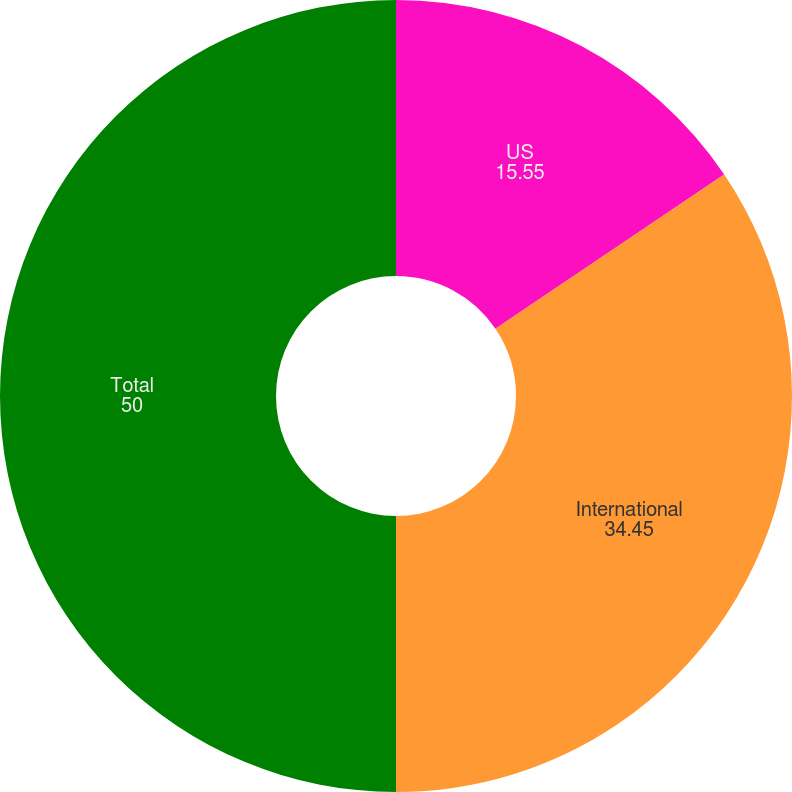Convert chart to OTSL. <chart><loc_0><loc_0><loc_500><loc_500><pie_chart><fcel>US<fcel>International<fcel>Total<nl><fcel>15.55%<fcel>34.45%<fcel>50.0%<nl></chart> 